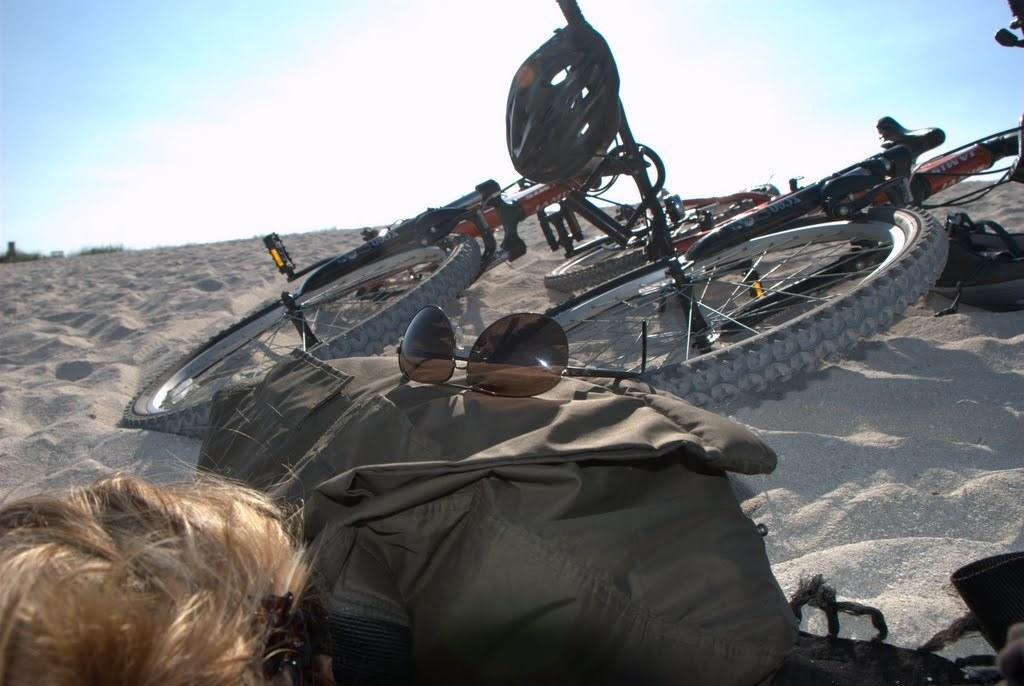Who or what is in the image? There is a person in the image. What is in front of the person? There is baggage, spectacles, bicycles, and a helmet in front of the person. Can you describe the items in front of the person? The person has baggage, spectacles, bicycles, and a helmet in front of them. What is the person in the image using the helmet for? The image does not provide information about the specific use of the helmet in this context. 